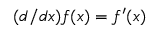<formula> <loc_0><loc_0><loc_500><loc_500>( d / d x ) f ( x ) = f ^ { \prime } ( x )</formula> 